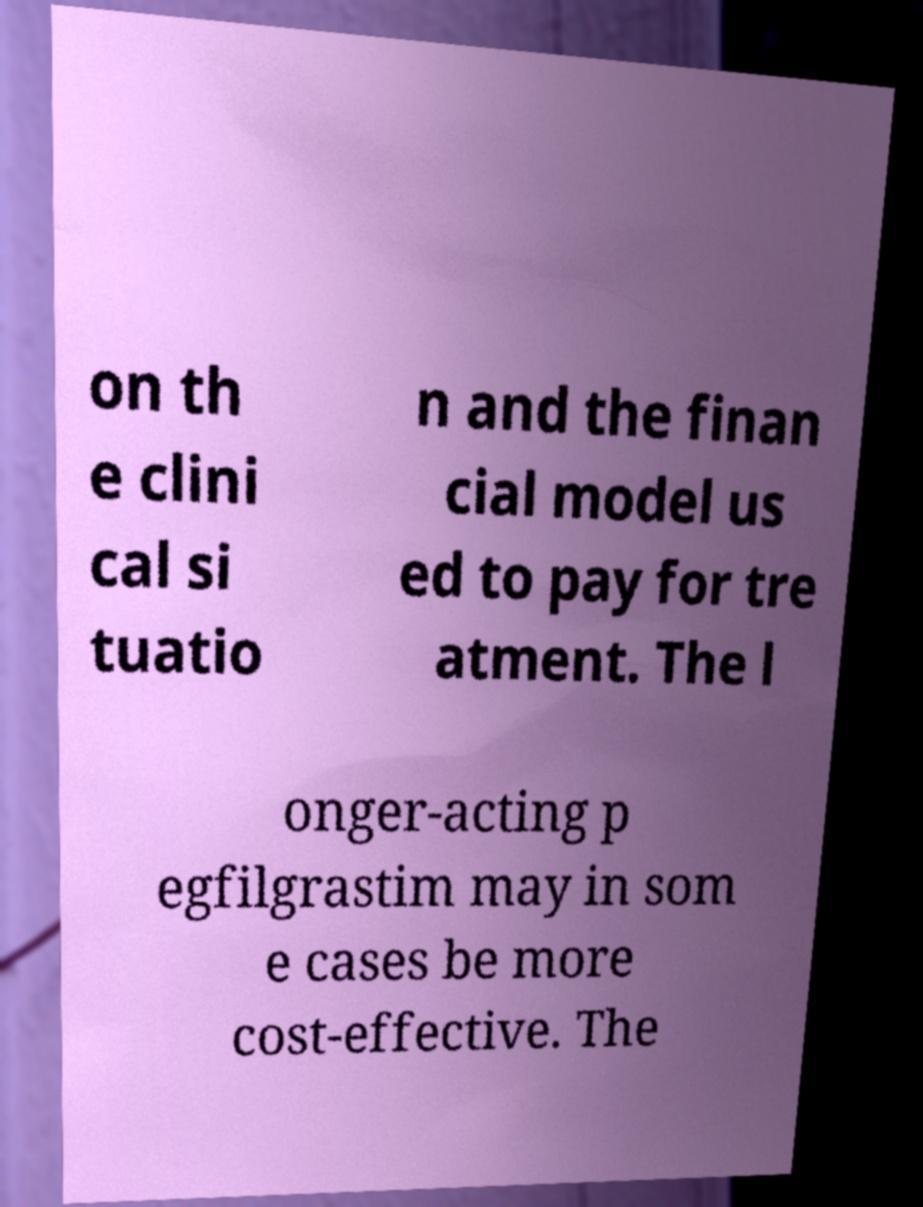I need the written content from this picture converted into text. Can you do that? on th e clini cal si tuatio n and the finan cial model us ed to pay for tre atment. The l onger-acting p egfilgrastim may in som e cases be more cost-effective. The 